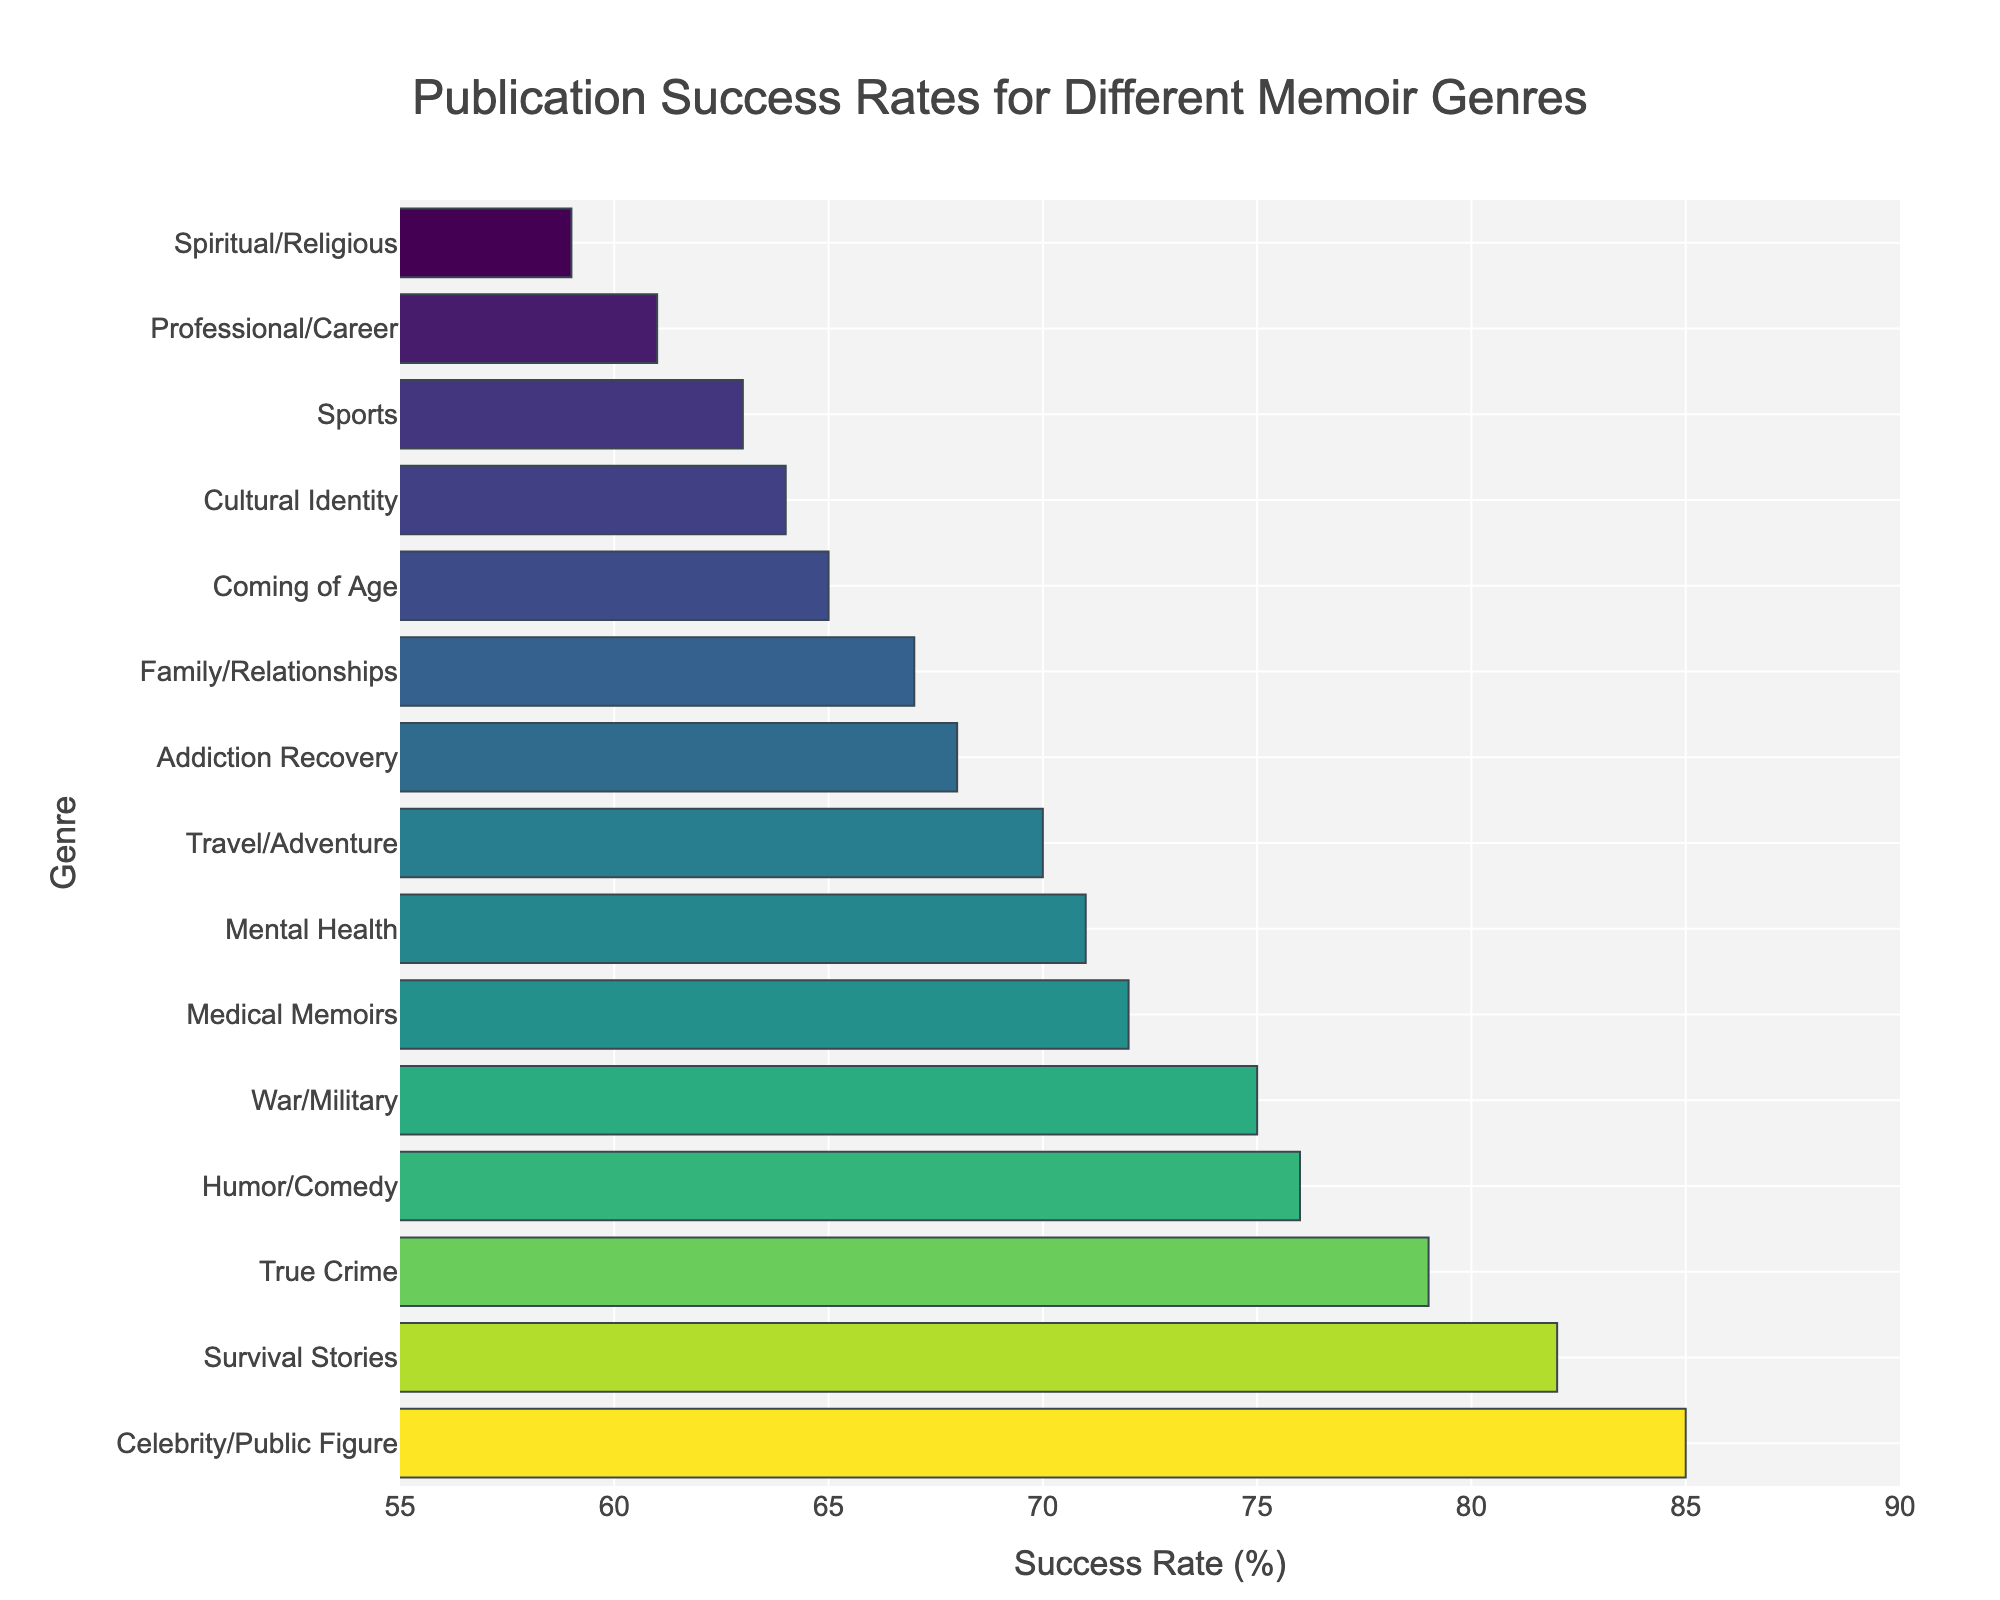What genre has the highest publication success rate? Look at the bar with the longest length (highest value) and note the genre it represents, which is "Celebrity/Public Figure" with a success rate of 85%.
Answer: Celebrity/Public Figure What is the difference in publication success rates between the highest and lowest genres? Identify the highest success rate (Celebrity/Public Figure with 85%) and the lowest success rate (Spiritual/Religious with 59%), then calculate the difference: 85% - 59% = 26%.
Answer: 26% How does the success rate of Medical Memoirs compare to Mental Health? Find the bars representing each genre: Medical Memoirs has a success rate of 72% and Mental Health has 71%. Compare the two values, Medical Memoirs is slightly higher.
Answer: Medical Memoirs is higher What is the average publication success rate of memoir genres with success rates above 75%? Identify genres with success rates above 75%: Celebrity/Public Figure (85%), True Crime (79%), Humor/Comedy (76%), Survival Stories (82%), War/Military (75%). Calculate the average of these values: (85 + 79 + 76 + 82 + 75) / 5 = 79.4%.
Answer: 79.4% Which two genres have the closest success rates? Look for bars with similar lengths. Medical Memoirs and Mental Health have close success rates of 72% and 71%, respectively.
Answer: Medical Memoirs and Mental Health Compare the publication success rates of Travel/Adventure and Addiction Recovery. Which is higher and by how much? Find the bars representing each genre: Travel/Adventure (70%) and Addiction Recovery (68%). Calculate the difference: 70% - 68% = 2%.
Answer: Travel/Adventure by 2% What is the median publication success rate across all genres? List the success rates in ascending order: 59, 61, 63, 64, 65, 67, 68, 70, 71, 72, 75, 76, 79, 82, 85. The median value is the middle of this list, which is the 8th value: 70%.
Answer: 70% How many genres have a publication success rate greater than 70%? Count the bars representing success rates above 70%: Medical Memoirs, Celebrity/Public Figure, War/Military, True Crime, Humor/Comedy, Survival Stories. There are 6 genres.
Answer: 6 What is the sum of the success rates of the three genres with the lowest rates? Identify the three lowest success rates: Spiritual/Religious (59%), Professional/Career (61%), Sports (63%). Sum these values: 59 + 61 + 63 = 183%.
Answer: 183% 